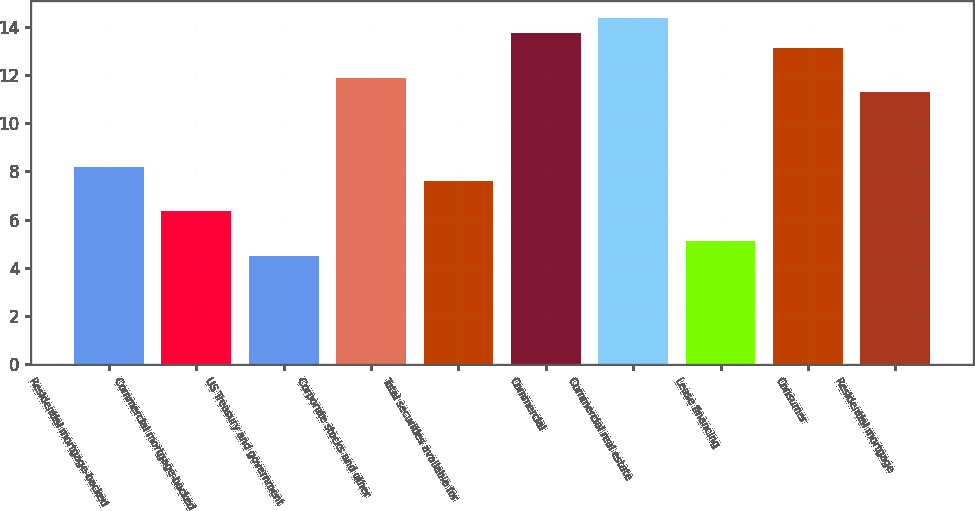<chart> <loc_0><loc_0><loc_500><loc_500><bar_chart><fcel>Residential mortgage-backed<fcel>Commercial mortgage-backed<fcel>US Treasury and government<fcel>Corporate stocks and other<fcel>Total securities available for<fcel>Commercial<fcel>Commercial real estate<fcel>Lease financing<fcel>Consumer<fcel>Residential mortgage<nl><fcel>8.2<fcel>6.35<fcel>4.49<fcel>11.88<fcel>7.58<fcel>13.73<fcel>14.35<fcel>5.11<fcel>13.12<fcel>11.27<nl></chart> 